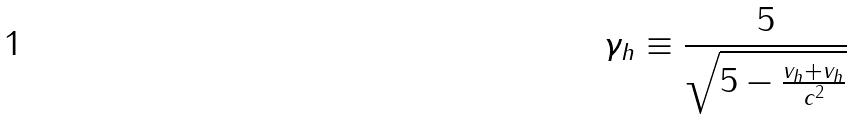<formula> <loc_0><loc_0><loc_500><loc_500>\gamma _ { h } \equiv \frac { 5 } { \sqrt { 5 - \frac { v _ { h } + v _ { h } } { c ^ { 2 } } } }</formula> 